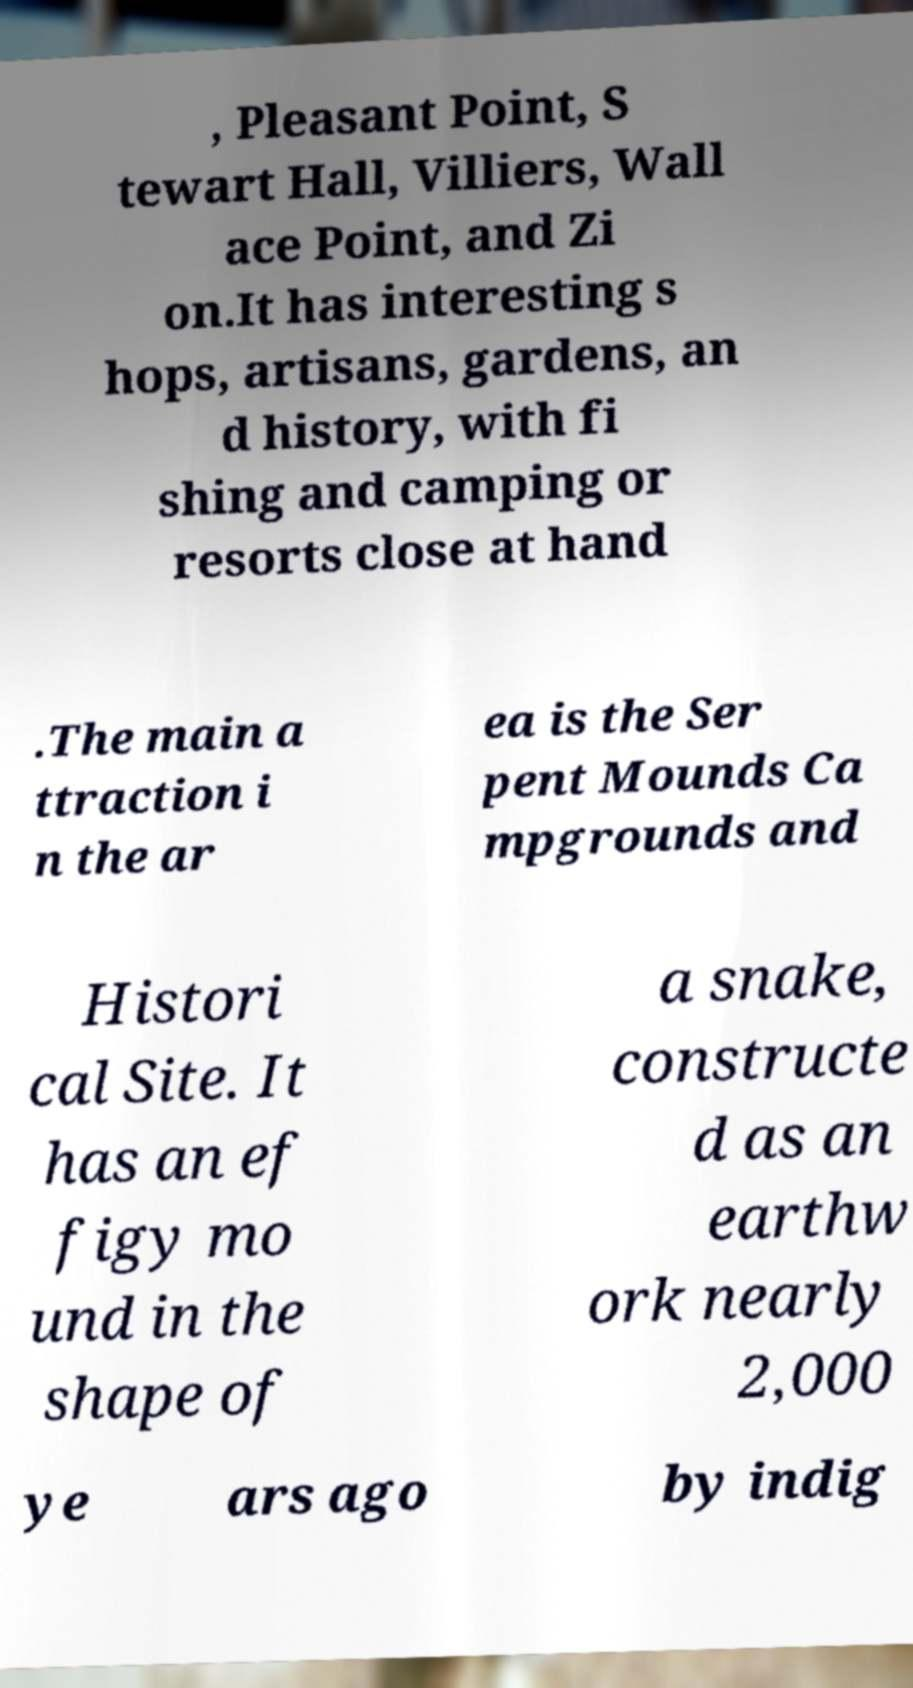Please identify and transcribe the text found in this image. , Pleasant Point, S tewart Hall, Villiers, Wall ace Point, and Zi on.It has interesting s hops, artisans, gardens, an d history, with fi shing and camping or resorts close at hand .The main a ttraction i n the ar ea is the Ser pent Mounds Ca mpgrounds and Histori cal Site. It has an ef figy mo und in the shape of a snake, constructe d as an earthw ork nearly 2,000 ye ars ago by indig 